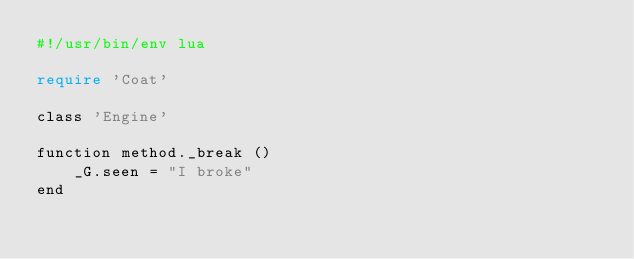Convert code to text. <code><loc_0><loc_0><loc_500><loc_500><_Perl_>#!/usr/bin/env lua

require 'Coat'

class 'Engine'

function method._break ()
    _G.seen = "I broke"
end
</code> 